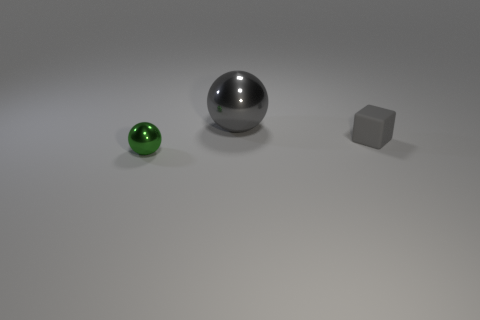Add 2 large purple blocks. How many objects exist? 5 Subtract all blocks. How many objects are left? 2 Subtract 0 purple cubes. How many objects are left? 3 Subtract all green objects. Subtract all big gray objects. How many objects are left? 1 Add 2 big metallic spheres. How many big metallic spheres are left? 3 Add 2 gray shiny balls. How many gray shiny balls exist? 3 